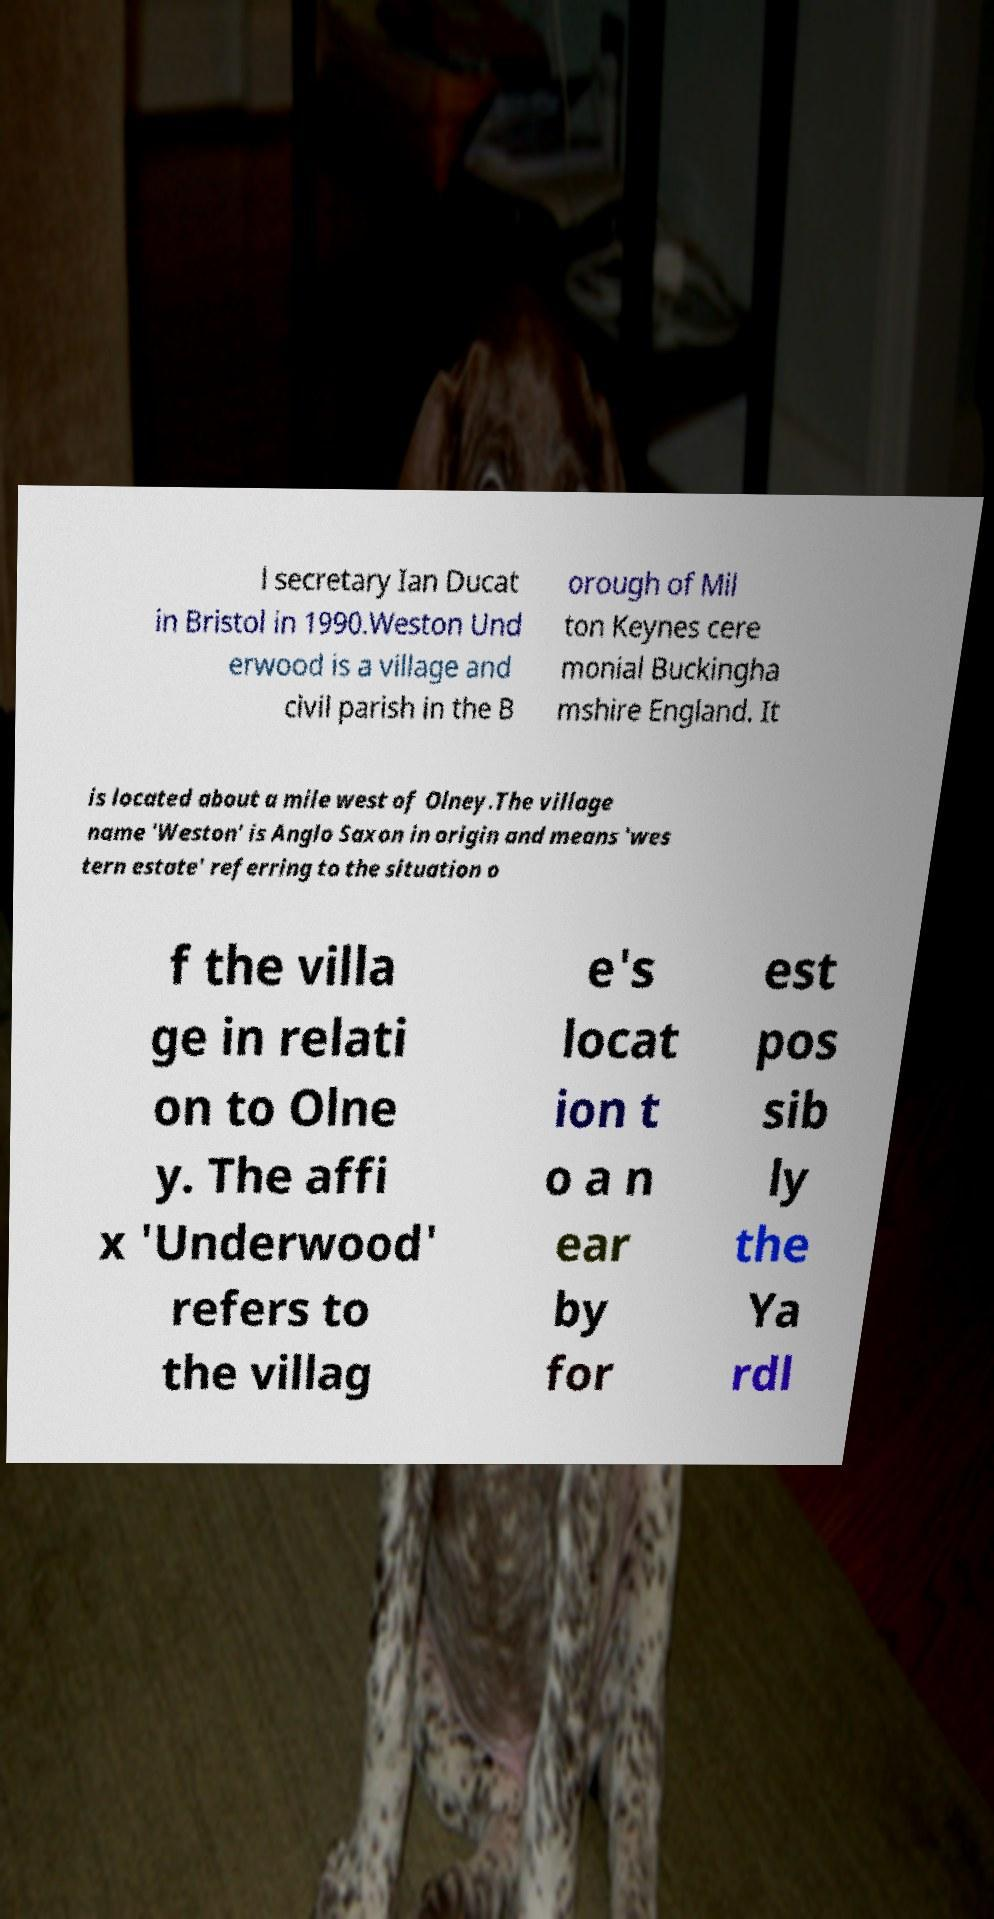Can you accurately transcribe the text from the provided image for me? l secretary Ian Ducat in Bristol in 1990.Weston Und erwood is a village and civil parish in the B orough of Mil ton Keynes cere monial Buckingha mshire England. It is located about a mile west of Olney.The village name 'Weston' is Anglo Saxon in origin and means 'wes tern estate' referring to the situation o f the villa ge in relati on to Olne y. The affi x 'Underwood' refers to the villag e's locat ion t o a n ear by for est pos sib ly the Ya rdl 